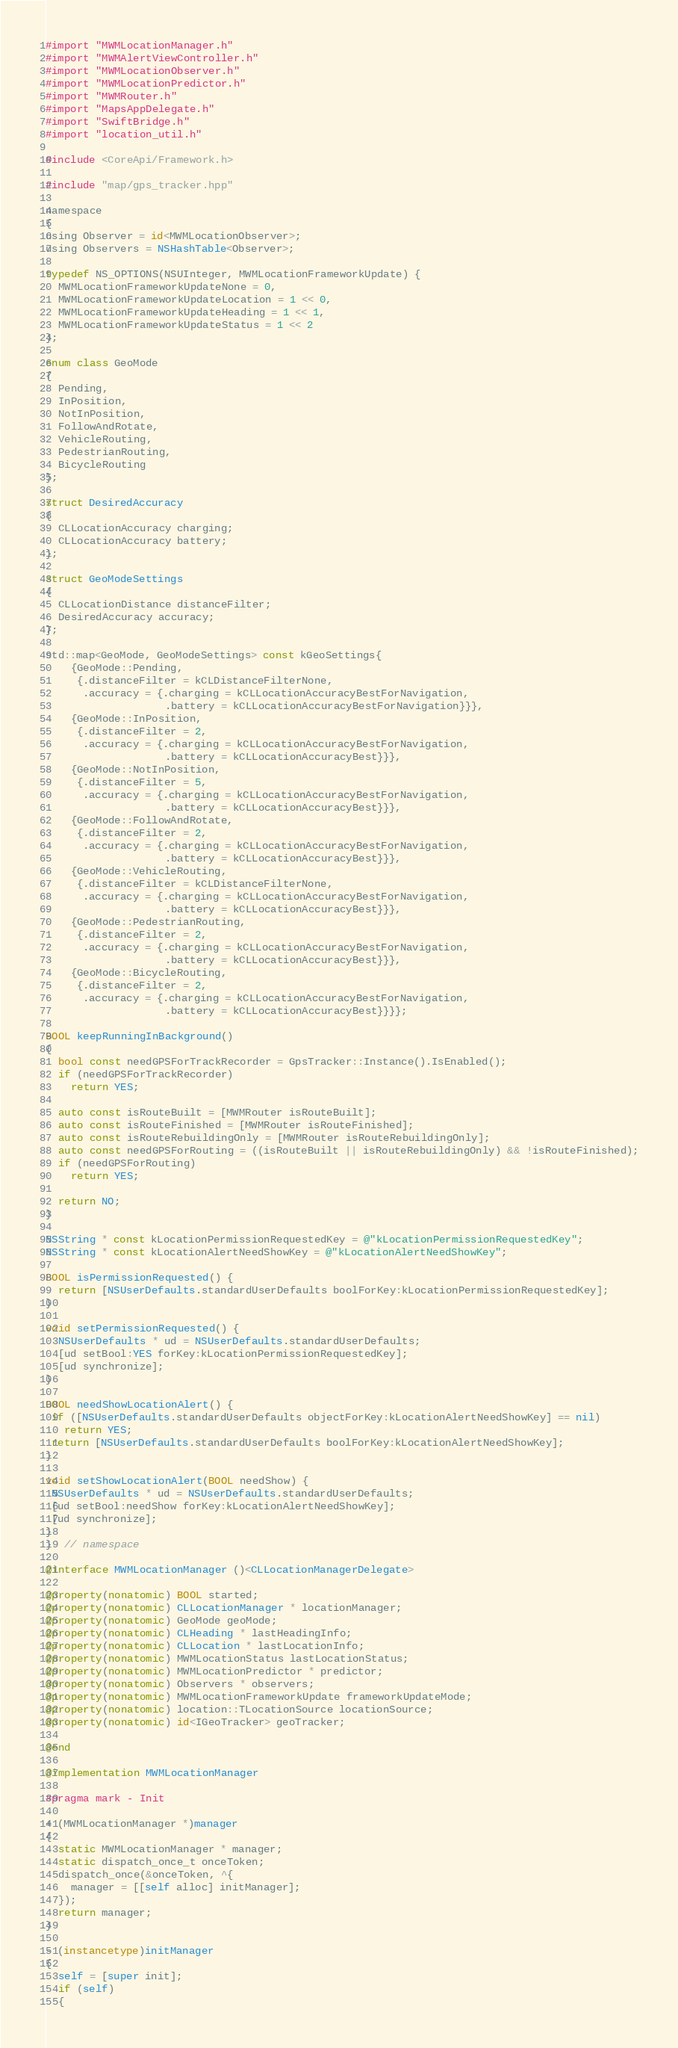Convert code to text. <code><loc_0><loc_0><loc_500><loc_500><_ObjectiveC_>#import "MWMLocationManager.h"
#import "MWMAlertViewController.h"
#import "MWMLocationObserver.h"
#import "MWMLocationPredictor.h"
#import "MWMRouter.h"
#import "MapsAppDelegate.h"
#import "SwiftBridge.h"
#import "location_util.h"

#include <CoreApi/Framework.h>

#include "map/gps_tracker.hpp"

namespace
{
using Observer = id<MWMLocationObserver>;
using Observers = NSHashTable<Observer>;

typedef NS_OPTIONS(NSUInteger, MWMLocationFrameworkUpdate) {
  MWMLocationFrameworkUpdateNone = 0,
  MWMLocationFrameworkUpdateLocation = 1 << 0,
  MWMLocationFrameworkUpdateHeading = 1 << 1,
  MWMLocationFrameworkUpdateStatus = 1 << 2
};

enum class GeoMode
{
  Pending,
  InPosition,
  NotInPosition,
  FollowAndRotate,
  VehicleRouting,
  PedestrianRouting,
  BicycleRouting
};

struct DesiredAccuracy
{
  CLLocationAccuracy charging;
  CLLocationAccuracy battery;
};

struct GeoModeSettings
{
  CLLocationDistance distanceFilter;
  DesiredAccuracy accuracy;
};

std::map<GeoMode, GeoModeSettings> const kGeoSettings{
    {GeoMode::Pending,
     {.distanceFilter = kCLDistanceFilterNone,
      .accuracy = {.charging = kCLLocationAccuracyBestForNavigation,
                   .battery = kCLLocationAccuracyBestForNavigation}}},
    {GeoMode::InPosition,
     {.distanceFilter = 2,
      .accuracy = {.charging = kCLLocationAccuracyBestForNavigation,
                   .battery = kCLLocationAccuracyBest}}},
    {GeoMode::NotInPosition,
     {.distanceFilter = 5,
      .accuracy = {.charging = kCLLocationAccuracyBestForNavigation,
                   .battery = kCLLocationAccuracyBest}}},
    {GeoMode::FollowAndRotate,
     {.distanceFilter = 2,
      .accuracy = {.charging = kCLLocationAccuracyBestForNavigation,
                   .battery = kCLLocationAccuracyBest}}},
    {GeoMode::VehicleRouting,
     {.distanceFilter = kCLDistanceFilterNone,
      .accuracy = {.charging = kCLLocationAccuracyBestForNavigation,
                   .battery = kCLLocationAccuracyBest}}},
    {GeoMode::PedestrianRouting,
     {.distanceFilter = 2,
      .accuracy = {.charging = kCLLocationAccuracyBestForNavigation,
                   .battery = kCLLocationAccuracyBest}}},
    {GeoMode::BicycleRouting,
     {.distanceFilter = 2,
      .accuracy = {.charging = kCLLocationAccuracyBestForNavigation,
                   .battery = kCLLocationAccuracyBest}}}};

BOOL keepRunningInBackground()
{
  bool const needGPSForTrackRecorder = GpsTracker::Instance().IsEnabled();
  if (needGPSForTrackRecorder)
    return YES;

  auto const isRouteBuilt = [MWMRouter isRouteBuilt];
  auto const isRouteFinished = [MWMRouter isRouteFinished];
  auto const isRouteRebuildingOnly = [MWMRouter isRouteRebuildingOnly];
  auto const needGPSForRouting = ((isRouteBuilt || isRouteRebuildingOnly) && !isRouteFinished);
  if (needGPSForRouting)
    return YES;

  return NO;
}

NSString * const kLocationPermissionRequestedKey = @"kLocationPermissionRequestedKey";
NSString * const kLocationAlertNeedShowKey = @"kLocationAlertNeedShowKey";

BOOL isPermissionRequested() {
  return [NSUserDefaults.standardUserDefaults boolForKey:kLocationPermissionRequestedKey];
}

void setPermissionRequested() {
  NSUserDefaults * ud = NSUserDefaults.standardUserDefaults;
  [ud setBool:YES forKey:kLocationPermissionRequestedKey];
  [ud synchronize];
}
       
BOOL needShowLocationAlert() {
 if ([NSUserDefaults.standardUserDefaults objectForKey:kLocationAlertNeedShowKey] == nil)
   return YES;
 return [NSUserDefaults.standardUserDefaults boolForKey:kLocationAlertNeedShowKey];
}

void setShowLocationAlert(BOOL needShow) {
 NSUserDefaults * ud = NSUserDefaults.standardUserDefaults;
 [ud setBool:needShow forKey:kLocationAlertNeedShowKey];
 [ud synchronize];
}
}  // namespace

@interface MWMLocationManager ()<CLLocationManagerDelegate>

@property(nonatomic) BOOL started;
@property(nonatomic) CLLocationManager * locationManager;
@property(nonatomic) GeoMode geoMode;
@property(nonatomic) CLHeading * lastHeadingInfo;
@property(nonatomic) CLLocation * lastLocationInfo;
@property(nonatomic) MWMLocationStatus lastLocationStatus;
@property(nonatomic) MWMLocationPredictor * predictor;
@property(nonatomic) Observers * observers;
@property(nonatomic) MWMLocationFrameworkUpdate frameworkUpdateMode;
@property(nonatomic) location::TLocationSource locationSource;
@property(nonatomic) id<IGeoTracker> geoTracker;

@end

@implementation MWMLocationManager

#pragma mark - Init

+ (MWMLocationManager *)manager
{
  static MWMLocationManager * manager;
  static dispatch_once_t onceToken;
  dispatch_once(&onceToken, ^{
    manager = [[self alloc] initManager];
  });
  return manager;
}

- (instancetype)initManager
{
  self = [super init];
  if (self)
  {</code> 